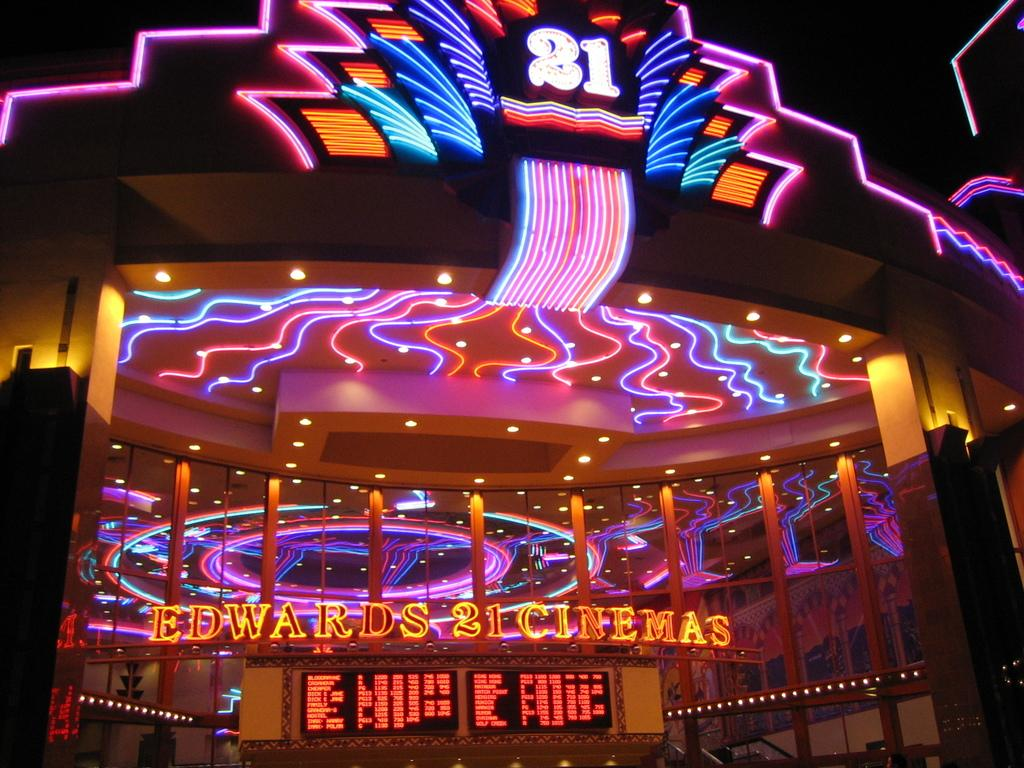What is the main object in the image? There is a screen in the image. What color is the screen? The screen is black in color. What can be seen in the background of the image? There are colorful lights in the background of the image. How many cherries are on the screen in the image? There are no cherries present on the screen in the image. Is the screen located inside a jail in the image? There is no indication of a jail or any confinement in the image; it only features a black screen and colorful lights in the background. 